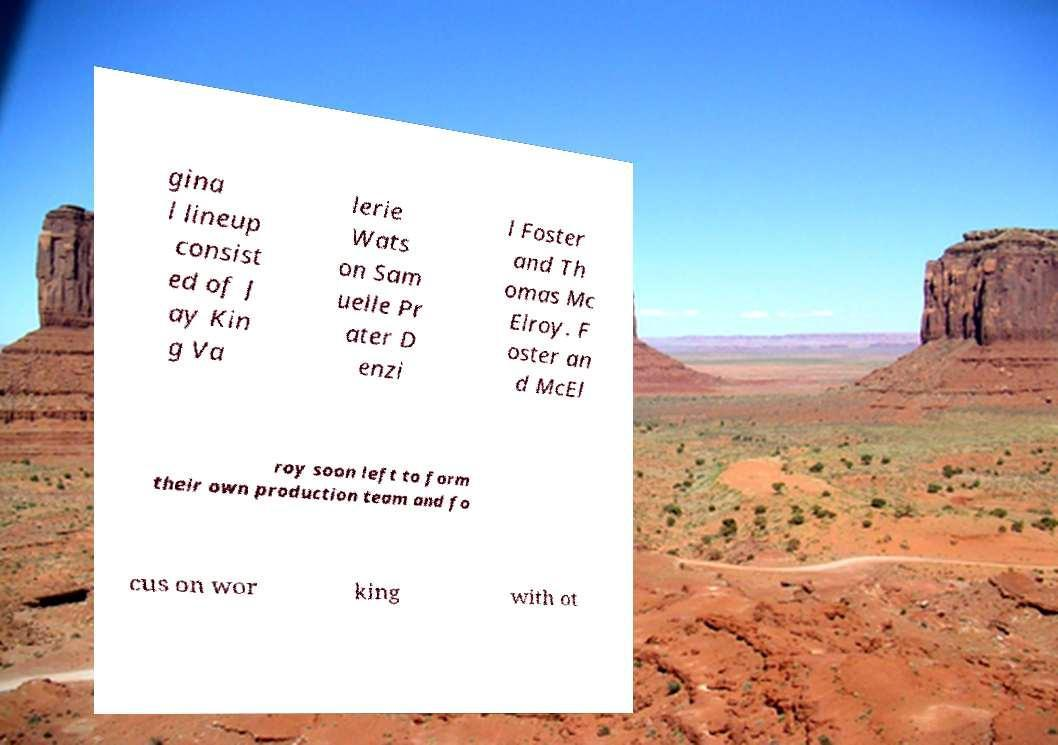Could you extract and type out the text from this image? gina l lineup consist ed of J ay Kin g Va lerie Wats on Sam uelle Pr ater D enzi l Foster and Th omas Mc Elroy. F oster an d McEl roy soon left to form their own production team and fo cus on wor king with ot 